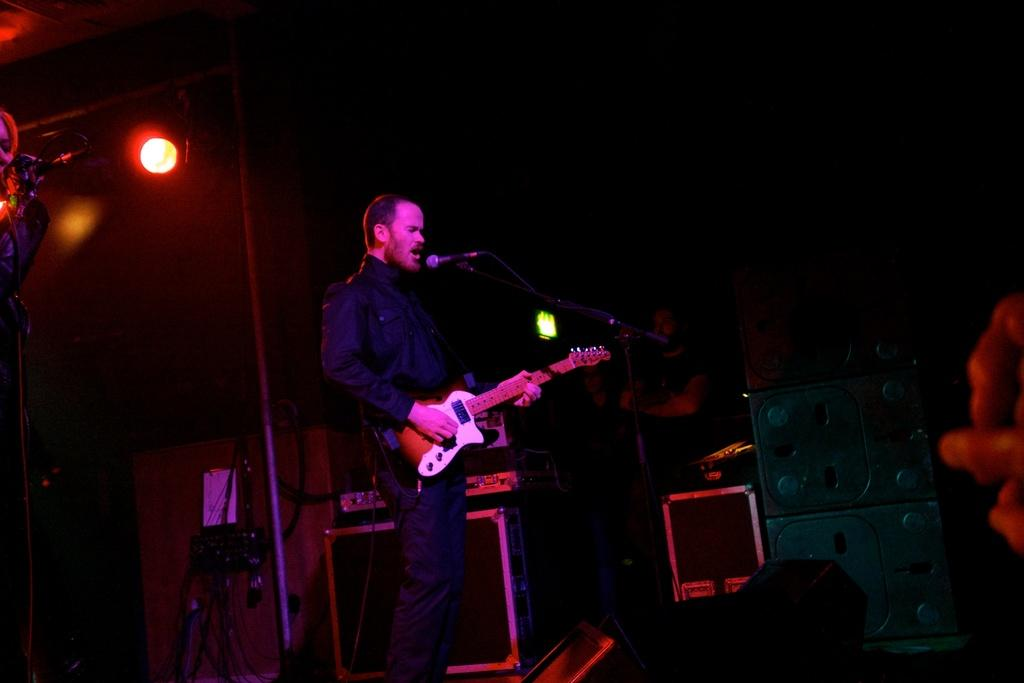What is the man in the image doing? The man is standing, playing a guitar, and singing into a microphone. What can be seen in the image besides the man? There are lights, musical instruments, and people visible in the image. What type of musical instruments are present in the image? There are musical instruments in the image, but the specific types are not mentioned in the facts. How many people are in the image? The number of people in the image is not specified in the facts. What type of hat is the man wearing in the image? There is no mention of a hat in the image, so it cannot be determined if the man is wearing one. 